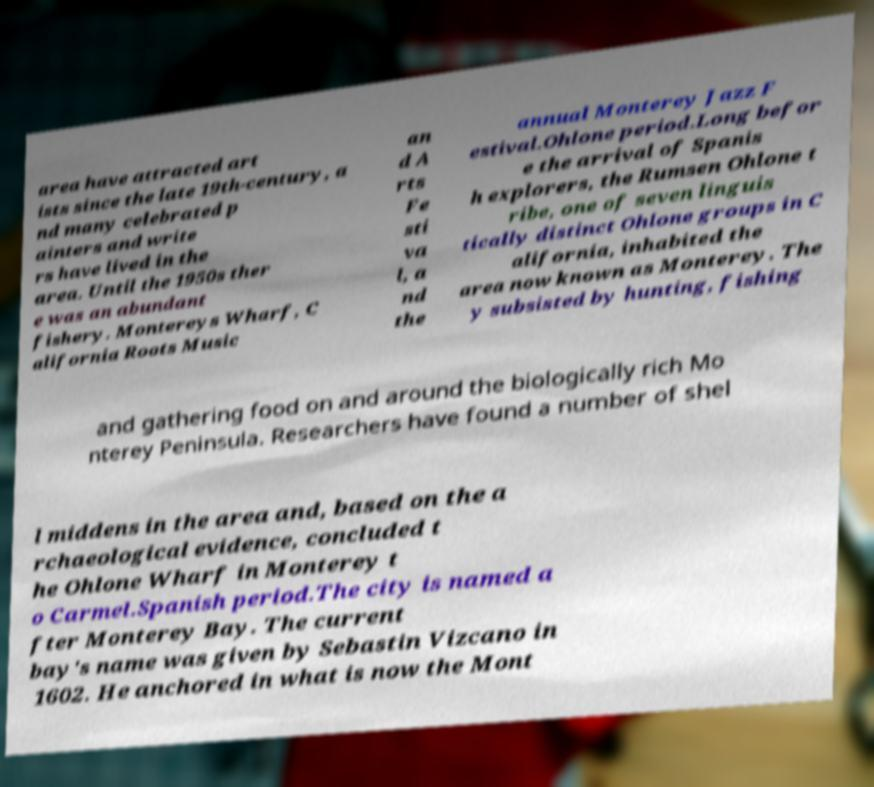Please identify and transcribe the text found in this image. area have attracted art ists since the late 19th-century, a nd many celebrated p ainters and write rs have lived in the area. Until the 1950s ther e was an abundant fishery. Montereys Wharf, C alifornia Roots Music an d A rts Fe sti va l, a nd the annual Monterey Jazz F estival.Ohlone period.Long befor e the arrival of Spanis h explorers, the Rumsen Ohlone t ribe, one of seven linguis tically distinct Ohlone groups in C alifornia, inhabited the area now known as Monterey. The y subsisted by hunting, fishing and gathering food on and around the biologically rich Mo nterey Peninsula. Researchers have found a number of shel l middens in the area and, based on the a rchaeological evidence, concluded t he Ohlone Wharf in Monterey t o Carmel.Spanish period.The city is named a fter Monterey Bay. The current bay's name was given by Sebastin Vizcano in 1602. He anchored in what is now the Mont 